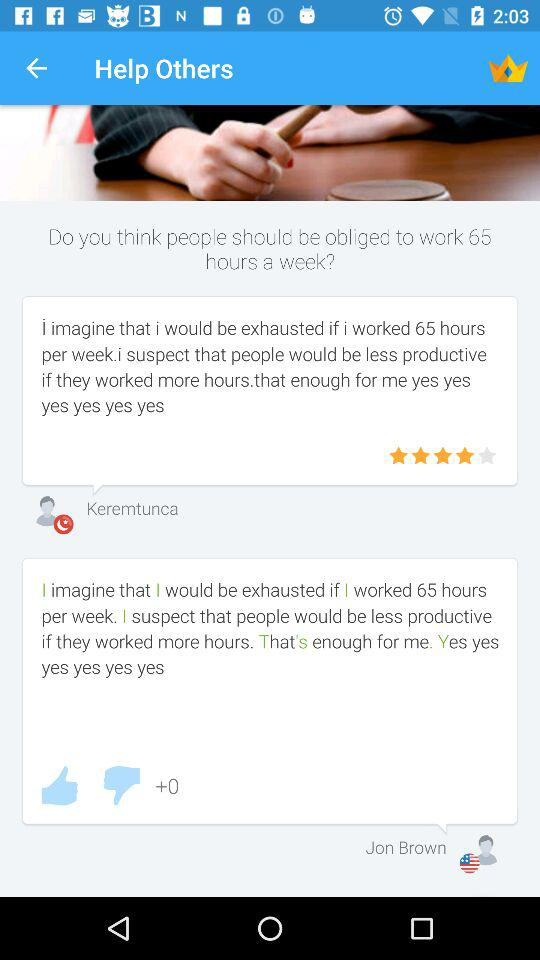What is the time duration of the working hours in a week? The time duration of the working hours in a week is 65. 